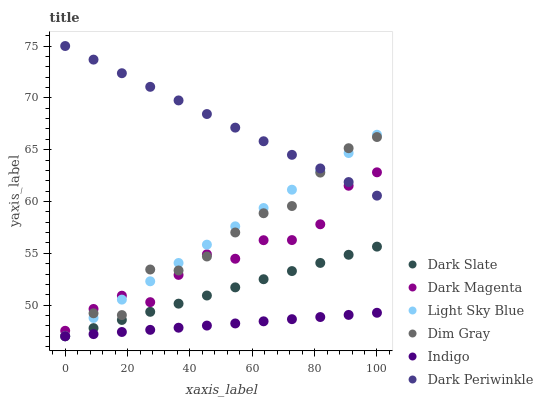Does Indigo have the minimum area under the curve?
Answer yes or no. Yes. Does Dark Periwinkle have the maximum area under the curve?
Answer yes or no. Yes. Does Dark Magenta have the minimum area under the curve?
Answer yes or no. No. Does Dark Magenta have the maximum area under the curve?
Answer yes or no. No. Is Light Sky Blue the smoothest?
Answer yes or no. Yes. Is Dim Gray the roughest?
Answer yes or no. Yes. Is Indigo the smoothest?
Answer yes or no. No. Is Indigo the roughest?
Answer yes or no. No. Does Dim Gray have the lowest value?
Answer yes or no. Yes. Does Dark Magenta have the lowest value?
Answer yes or no. No. Does Dark Periwinkle have the highest value?
Answer yes or no. Yes. Does Dark Magenta have the highest value?
Answer yes or no. No. Is Dark Slate less than Dark Periwinkle?
Answer yes or no. Yes. Is Dark Magenta greater than Indigo?
Answer yes or no. Yes. Does Dim Gray intersect Light Sky Blue?
Answer yes or no. Yes. Is Dim Gray less than Light Sky Blue?
Answer yes or no. No. Is Dim Gray greater than Light Sky Blue?
Answer yes or no. No. Does Dark Slate intersect Dark Periwinkle?
Answer yes or no. No. 